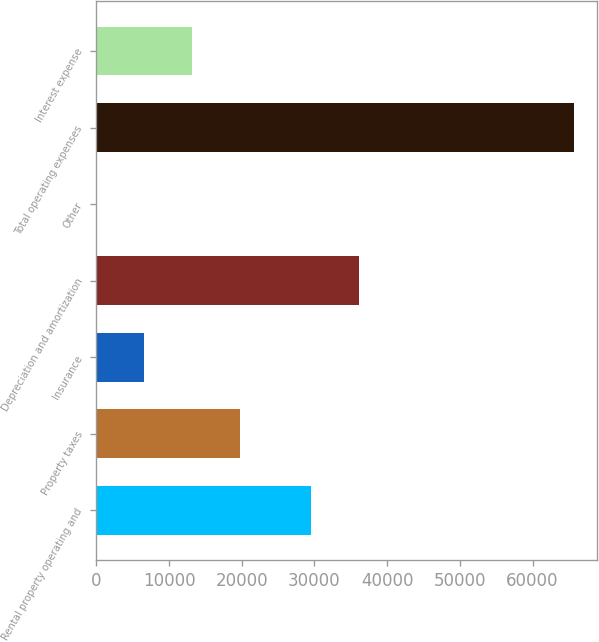<chart> <loc_0><loc_0><loc_500><loc_500><bar_chart><fcel>Rental property operating and<fcel>Property taxes<fcel>Insurance<fcel>Depreciation and amortization<fcel>Other<fcel>Total operating expenses<fcel>Interest expense<nl><fcel>29510<fcel>19722.7<fcel>6602.9<fcel>36069.9<fcel>43<fcel>65642<fcel>13162.8<nl></chart> 